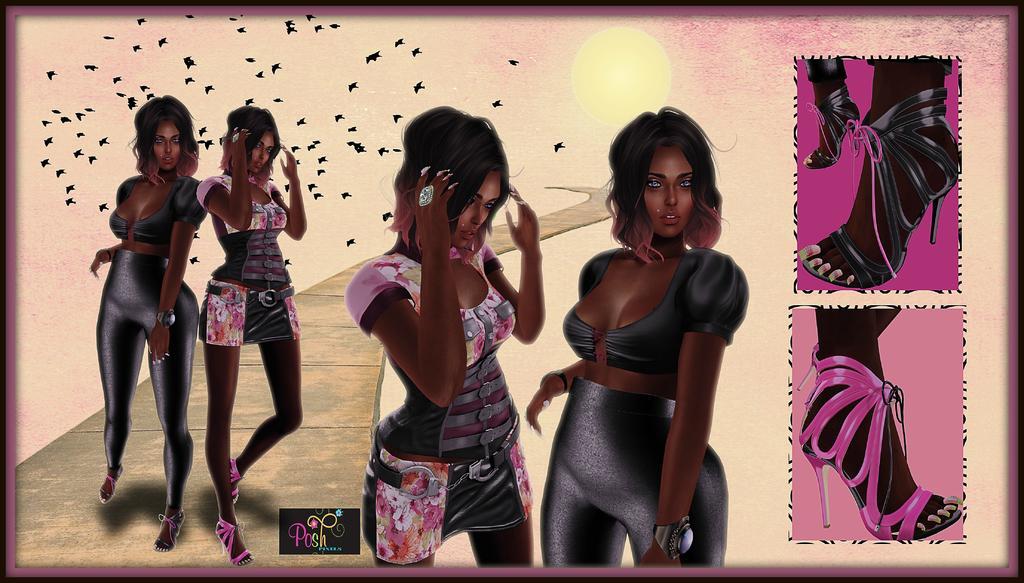Could you give a brief overview of what you see in this image? In this image we can see there is a painting of two girls on the left and middle and on the right there is a footwear of girls. 